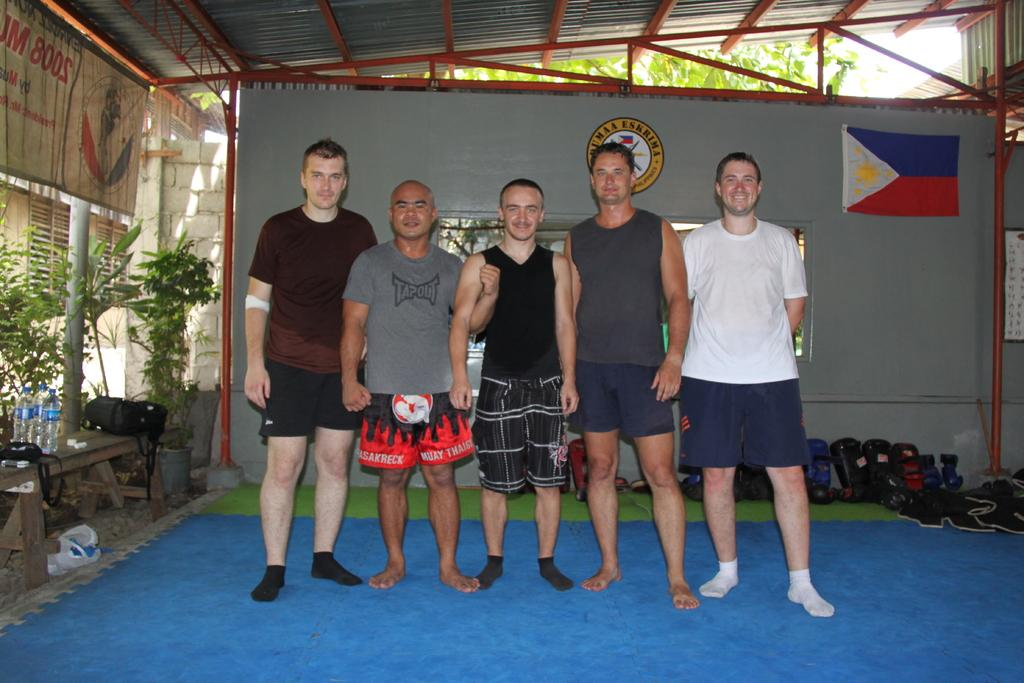<image>
Share a concise interpretation of the image provided. A man is wearing a gray shirt with the Tapout logo on the front. 